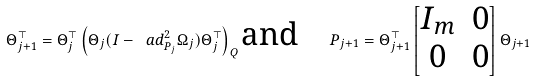Convert formula to latex. <formula><loc_0><loc_0><loc_500><loc_500>\Theta _ { j + 1 } ^ { \top } = \Theta _ { j } ^ { \top } \left ( \Theta _ { j } ( I - \ a d _ { P _ { j } } ^ { 2 } \Omega _ { j } ) \Theta _ { j } ^ { \top } \right ) _ { Q } \text {and} \quad P _ { j + 1 } = \Theta _ { j + 1 } ^ { \top } \begin{bmatrix} I _ { m } & 0 \\ 0 & 0 \end{bmatrix} \Theta _ { j + 1 }</formula> 